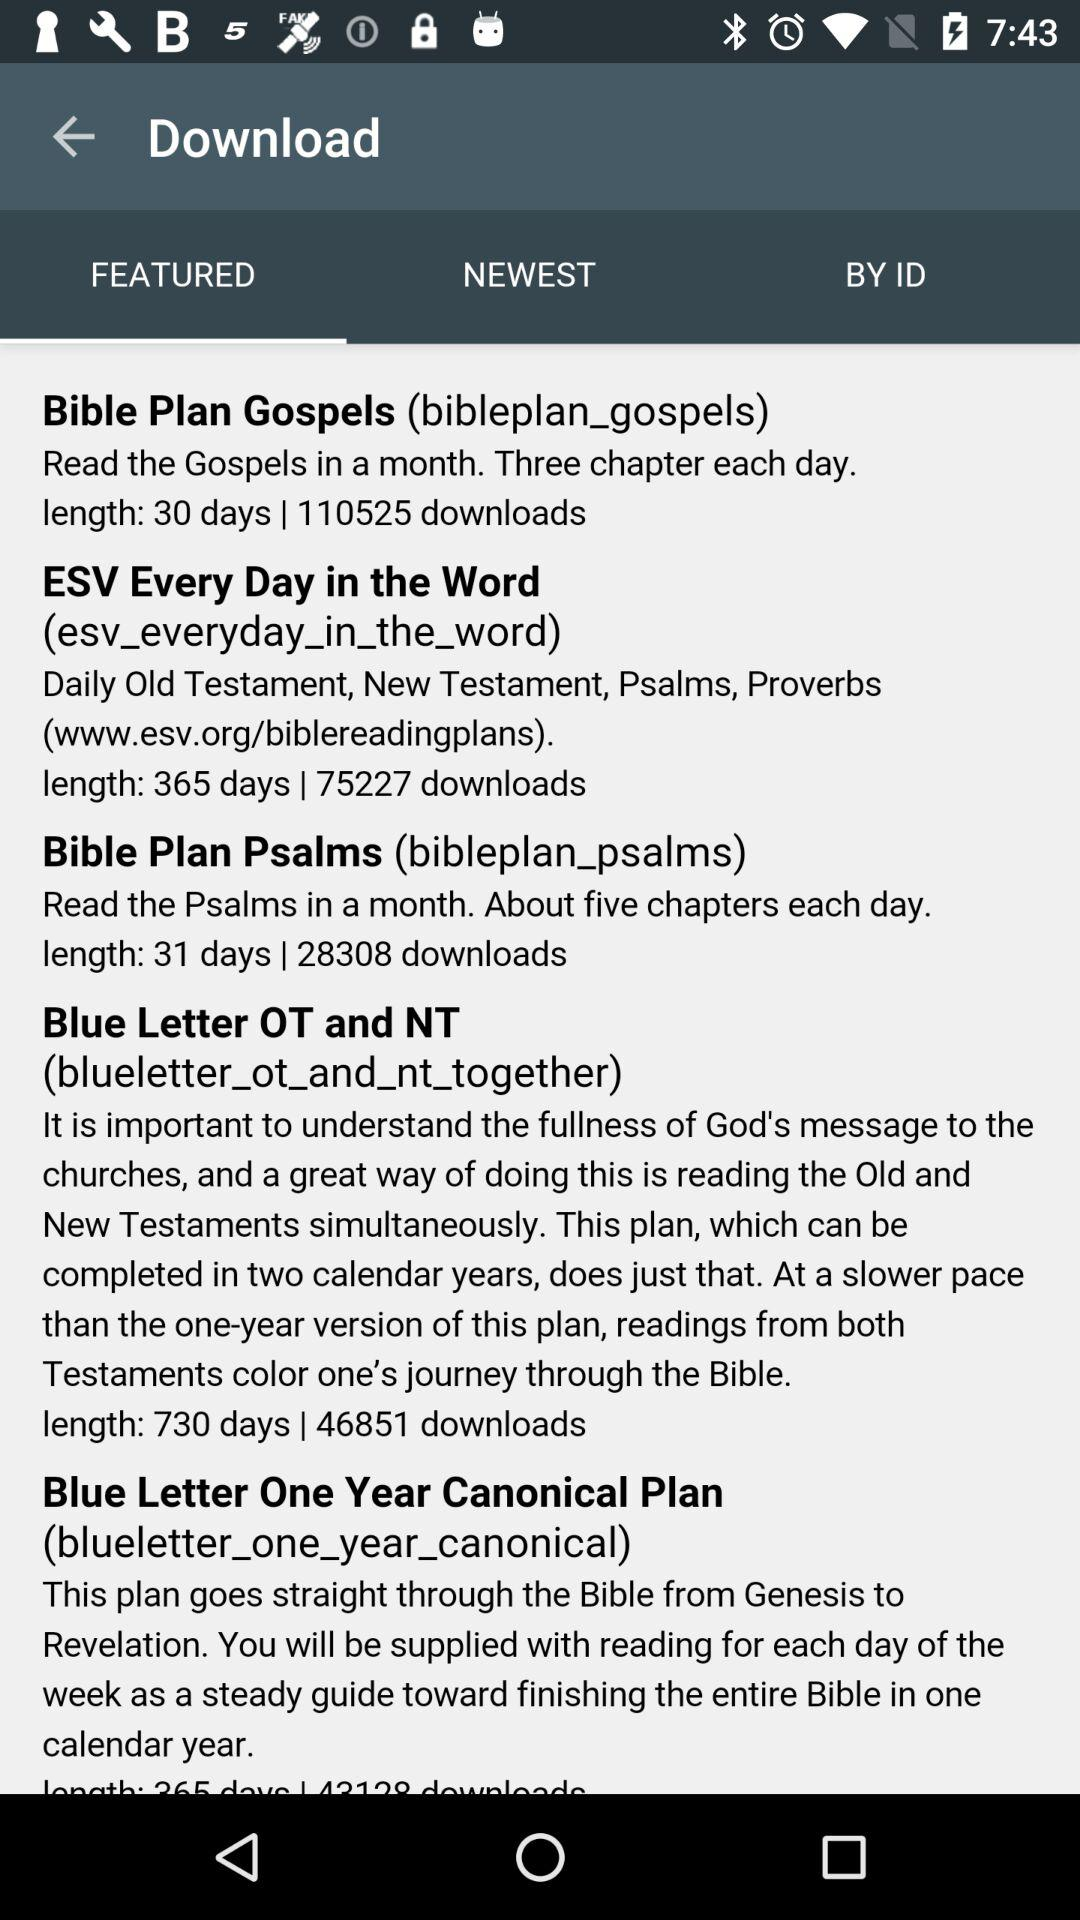What is the length of the ESV every day in the word? The length is 365 days. 